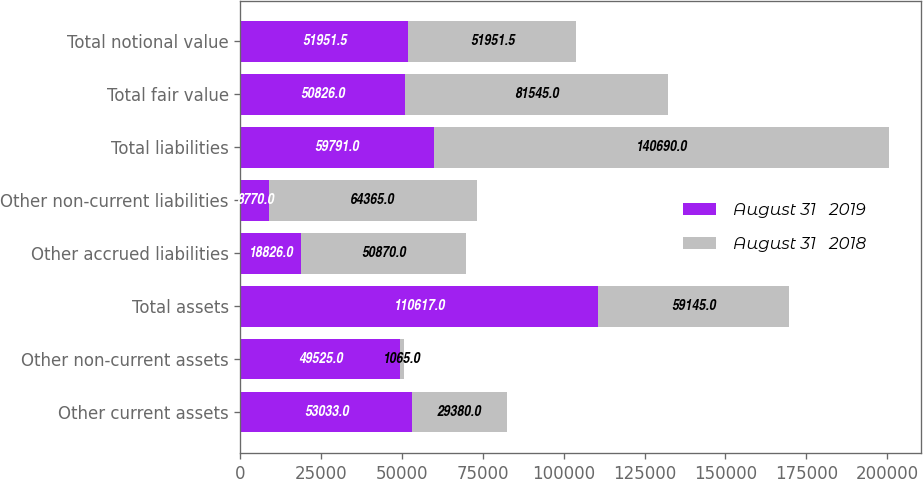Convert chart. <chart><loc_0><loc_0><loc_500><loc_500><stacked_bar_chart><ecel><fcel>Other current assets<fcel>Other non-current assets<fcel>Total assets<fcel>Other accrued liabilities<fcel>Other non-current liabilities<fcel>Total liabilities<fcel>Total fair value<fcel>Total notional value<nl><fcel>August 31   2019<fcel>53033<fcel>49525<fcel>110617<fcel>18826<fcel>8770<fcel>59791<fcel>50826<fcel>51951.5<nl><fcel>August 31   2018<fcel>29380<fcel>1065<fcel>59145<fcel>50870<fcel>64365<fcel>140690<fcel>81545<fcel>51951.5<nl></chart> 